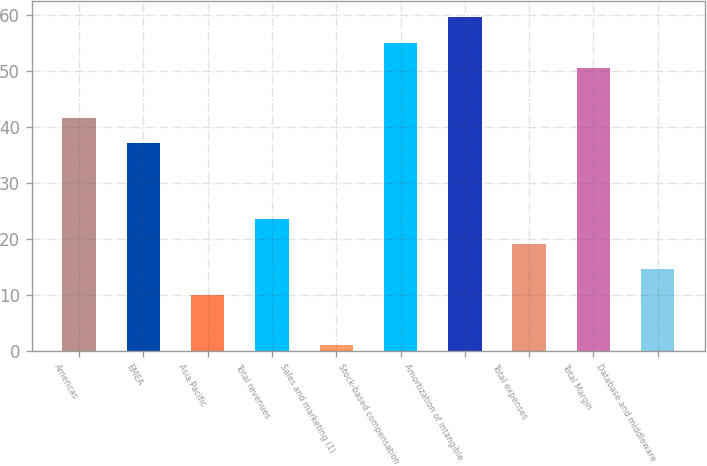<chart> <loc_0><loc_0><loc_500><loc_500><bar_chart><fcel>Americas<fcel>EMEA<fcel>Asia Pacific<fcel>Total revenues<fcel>Sales and marketing (1)<fcel>Stock-based compensation<fcel>Amortization of intangible<fcel>Total expenses<fcel>Total Margin<fcel>Database and middleware<nl><fcel>41.5<fcel>37<fcel>10<fcel>23.5<fcel>1<fcel>55<fcel>59.5<fcel>19<fcel>50.5<fcel>14.5<nl></chart> 